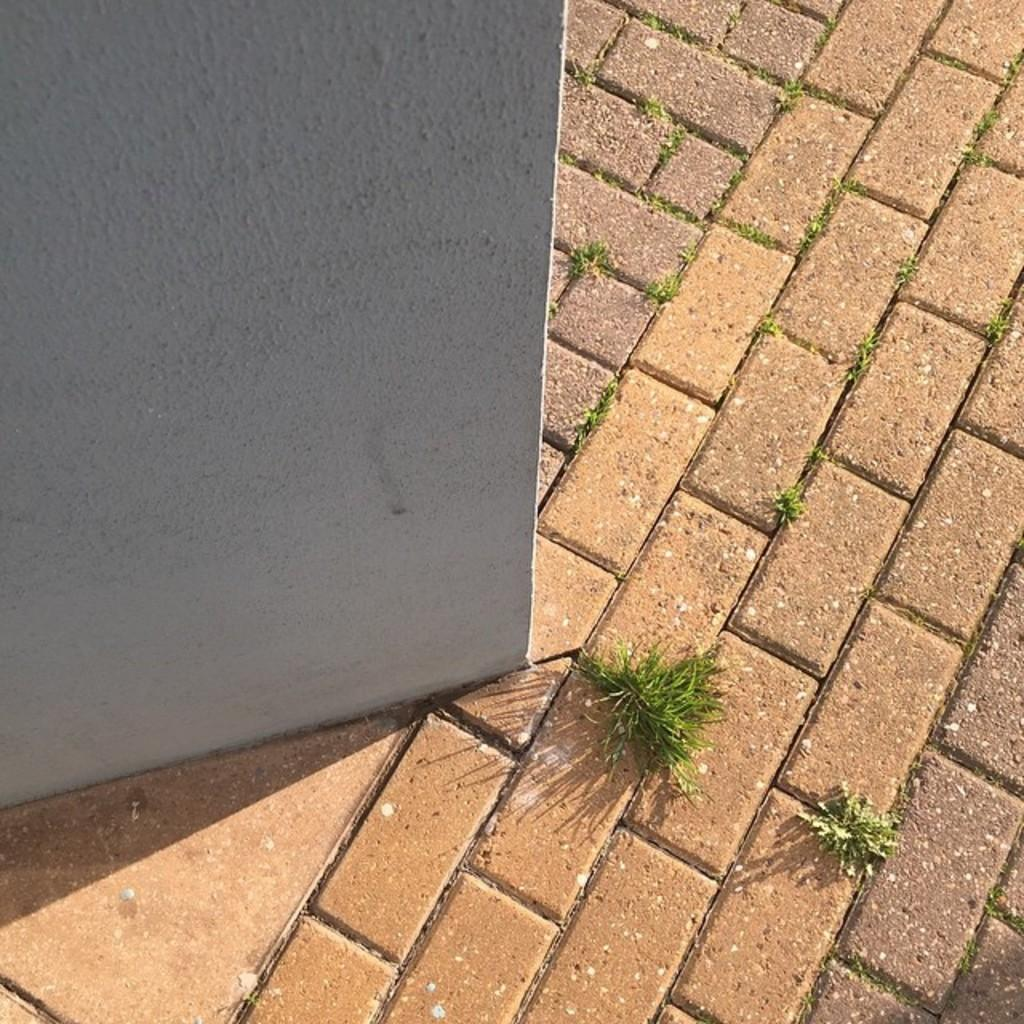What type of surface is present on the path in the image? There is grass on the path in the image. What can be seen in the background of the image? There is a wall visible in the background of the image. How many nails are used to hold the drum in the image? There is no drum present in the image, so it is not possible to determine how many nails might be used to hold it. 